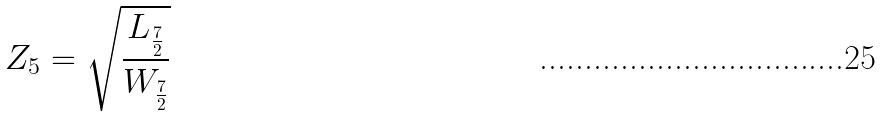Convert formula to latex. <formula><loc_0><loc_0><loc_500><loc_500>Z _ { 5 } = \sqrt { \frac { L _ { \frac { 7 } { 2 } } } { W _ { \frac { 7 } { 2 } } } }</formula> 